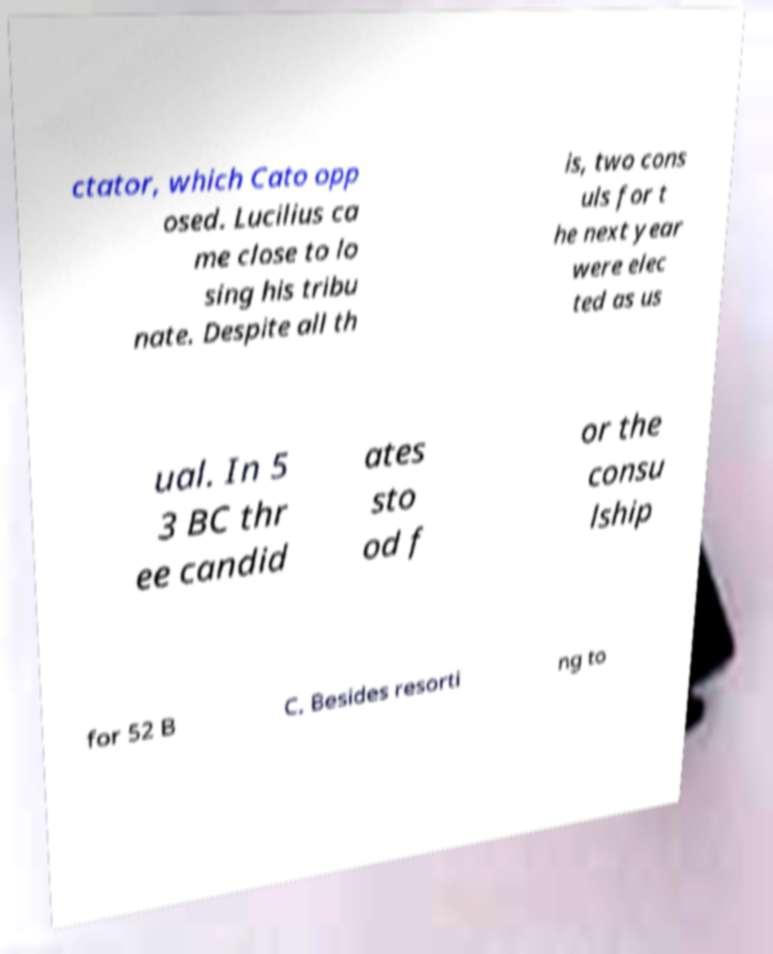For documentation purposes, I need the text within this image transcribed. Could you provide that? ctator, which Cato opp osed. Lucilius ca me close to lo sing his tribu nate. Despite all th is, two cons uls for t he next year were elec ted as us ual. In 5 3 BC thr ee candid ates sto od f or the consu lship for 52 B C. Besides resorti ng to 